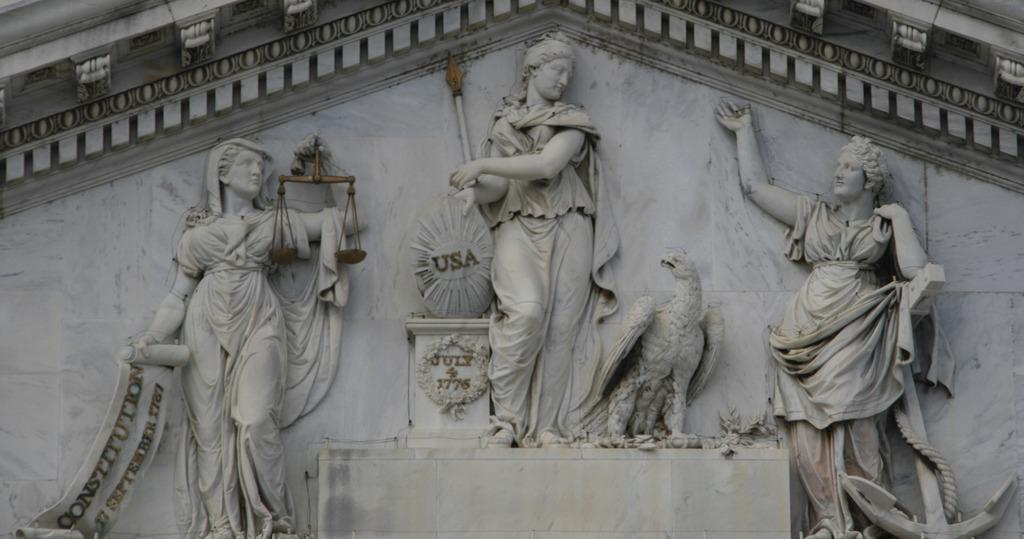What type of sculptures can be seen in the image? There are sculptures of women and an eagle in the image. Where are the sculptures located? The sculptures are on the wall. What type of impulse can be seen affecting the sculptures in the image? There is no impulse affecting the sculptures in the image; they are stationary and not moving. Is there any popcorn visible in the image? There is no popcorn present in the image. 